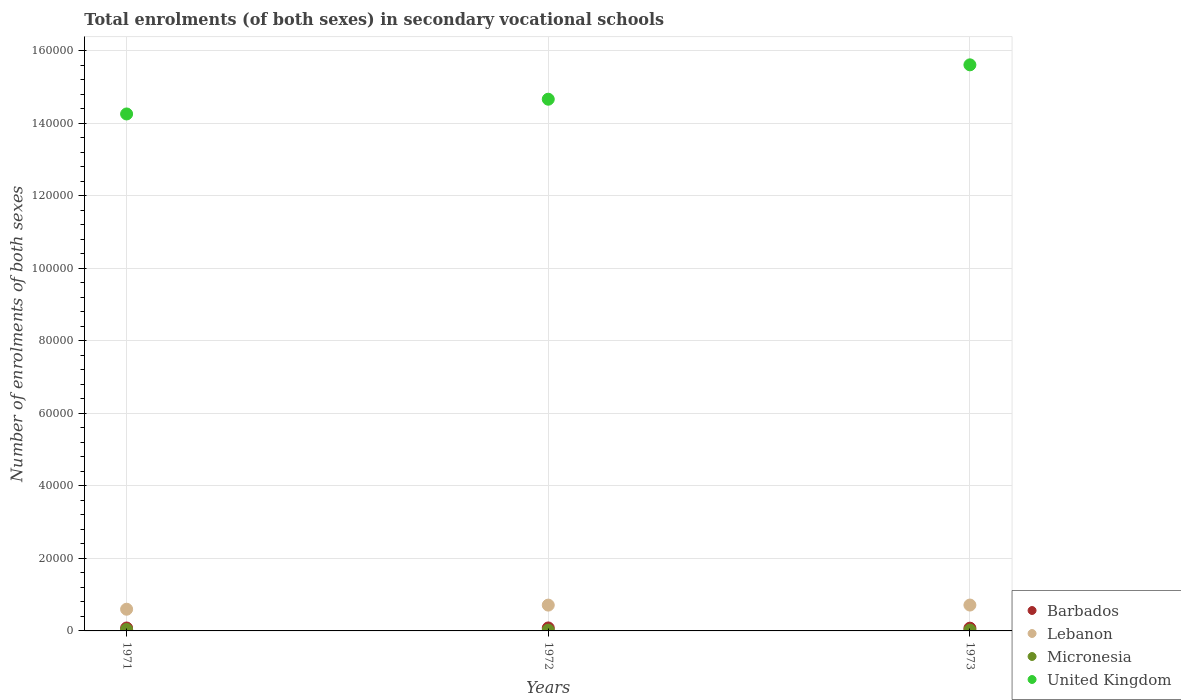How many different coloured dotlines are there?
Offer a very short reply. 4. What is the number of enrolments in secondary schools in Micronesia in 1973?
Offer a terse response. 226. Across all years, what is the maximum number of enrolments in secondary schools in United Kingdom?
Keep it short and to the point. 1.56e+05. Across all years, what is the minimum number of enrolments in secondary schools in Barbados?
Your response must be concise. 761. What is the total number of enrolments in secondary schools in Lebanon in the graph?
Provide a succinct answer. 2.02e+04. What is the difference between the number of enrolments in secondary schools in Micronesia in 1973 and the number of enrolments in secondary schools in Barbados in 1972?
Provide a short and direct response. -596. What is the average number of enrolments in secondary schools in Barbados per year?
Offer a terse response. 796.33. In the year 1971, what is the difference between the number of enrolments in secondary schools in United Kingdom and number of enrolments in secondary schools in Barbados?
Ensure brevity in your answer.  1.42e+05. In how many years, is the number of enrolments in secondary schools in United Kingdom greater than 8000?
Provide a succinct answer. 3. What is the ratio of the number of enrolments in secondary schools in Barbados in 1971 to that in 1973?
Give a very brief answer. 1.06. Is the number of enrolments in secondary schools in Micronesia in 1971 less than that in 1973?
Make the answer very short. No. What is the difference between the highest and the second highest number of enrolments in secondary schools in United Kingdom?
Provide a short and direct response. 9479. What is the difference between the highest and the lowest number of enrolments in secondary schools in Lebanon?
Your answer should be very brief. 1150. In how many years, is the number of enrolments in secondary schools in United Kingdom greater than the average number of enrolments in secondary schools in United Kingdom taken over all years?
Offer a very short reply. 1. Is it the case that in every year, the sum of the number of enrolments in secondary schools in United Kingdom and number of enrolments in secondary schools in Lebanon  is greater than the sum of number of enrolments in secondary schools in Micronesia and number of enrolments in secondary schools in Barbados?
Provide a succinct answer. Yes. Is it the case that in every year, the sum of the number of enrolments in secondary schools in Barbados and number of enrolments in secondary schools in United Kingdom  is greater than the number of enrolments in secondary schools in Micronesia?
Offer a very short reply. Yes. Is the number of enrolments in secondary schools in United Kingdom strictly less than the number of enrolments in secondary schools in Barbados over the years?
Keep it short and to the point. No. How many years are there in the graph?
Give a very brief answer. 3. What is the difference between two consecutive major ticks on the Y-axis?
Keep it short and to the point. 2.00e+04. Does the graph contain any zero values?
Your answer should be compact. No. Does the graph contain grids?
Keep it short and to the point. Yes. Where does the legend appear in the graph?
Provide a succinct answer. Bottom right. How many legend labels are there?
Your answer should be very brief. 4. What is the title of the graph?
Provide a short and direct response. Total enrolments (of both sexes) in secondary vocational schools. What is the label or title of the Y-axis?
Your answer should be very brief. Number of enrolments of both sexes. What is the Number of enrolments of both sexes in Barbados in 1971?
Give a very brief answer. 806. What is the Number of enrolments of both sexes of Lebanon in 1971?
Make the answer very short. 5983. What is the Number of enrolments of both sexes in Micronesia in 1971?
Provide a succinct answer. 409. What is the Number of enrolments of both sexes in United Kingdom in 1971?
Your answer should be compact. 1.43e+05. What is the Number of enrolments of both sexes in Barbados in 1972?
Your answer should be compact. 822. What is the Number of enrolments of both sexes in Lebanon in 1972?
Make the answer very short. 7117. What is the Number of enrolments of both sexes of Micronesia in 1972?
Ensure brevity in your answer.  215. What is the Number of enrolments of both sexes in United Kingdom in 1972?
Offer a terse response. 1.47e+05. What is the Number of enrolments of both sexes in Barbados in 1973?
Your answer should be compact. 761. What is the Number of enrolments of both sexes in Lebanon in 1973?
Ensure brevity in your answer.  7133. What is the Number of enrolments of both sexes in Micronesia in 1973?
Your answer should be very brief. 226. What is the Number of enrolments of both sexes of United Kingdom in 1973?
Your response must be concise. 1.56e+05. Across all years, what is the maximum Number of enrolments of both sexes in Barbados?
Offer a very short reply. 822. Across all years, what is the maximum Number of enrolments of both sexes of Lebanon?
Ensure brevity in your answer.  7133. Across all years, what is the maximum Number of enrolments of both sexes in Micronesia?
Offer a very short reply. 409. Across all years, what is the maximum Number of enrolments of both sexes of United Kingdom?
Keep it short and to the point. 1.56e+05. Across all years, what is the minimum Number of enrolments of both sexes in Barbados?
Offer a terse response. 761. Across all years, what is the minimum Number of enrolments of both sexes in Lebanon?
Ensure brevity in your answer.  5983. Across all years, what is the minimum Number of enrolments of both sexes of Micronesia?
Ensure brevity in your answer.  215. Across all years, what is the minimum Number of enrolments of both sexes in United Kingdom?
Provide a short and direct response. 1.43e+05. What is the total Number of enrolments of both sexes of Barbados in the graph?
Ensure brevity in your answer.  2389. What is the total Number of enrolments of both sexes in Lebanon in the graph?
Your response must be concise. 2.02e+04. What is the total Number of enrolments of both sexes in Micronesia in the graph?
Make the answer very short. 850. What is the total Number of enrolments of both sexes of United Kingdom in the graph?
Keep it short and to the point. 4.45e+05. What is the difference between the Number of enrolments of both sexes in Barbados in 1971 and that in 1972?
Provide a short and direct response. -16. What is the difference between the Number of enrolments of both sexes in Lebanon in 1971 and that in 1972?
Your response must be concise. -1134. What is the difference between the Number of enrolments of both sexes in Micronesia in 1971 and that in 1972?
Make the answer very short. 194. What is the difference between the Number of enrolments of both sexes in United Kingdom in 1971 and that in 1972?
Provide a succinct answer. -4064. What is the difference between the Number of enrolments of both sexes in Lebanon in 1971 and that in 1973?
Offer a very short reply. -1150. What is the difference between the Number of enrolments of both sexes in Micronesia in 1971 and that in 1973?
Keep it short and to the point. 183. What is the difference between the Number of enrolments of both sexes of United Kingdom in 1971 and that in 1973?
Offer a terse response. -1.35e+04. What is the difference between the Number of enrolments of both sexes in Lebanon in 1972 and that in 1973?
Provide a succinct answer. -16. What is the difference between the Number of enrolments of both sexes of United Kingdom in 1972 and that in 1973?
Ensure brevity in your answer.  -9479. What is the difference between the Number of enrolments of both sexes in Barbados in 1971 and the Number of enrolments of both sexes in Lebanon in 1972?
Provide a short and direct response. -6311. What is the difference between the Number of enrolments of both sexes of Barbados in 1971 and the Number of enrolments of both sexes of Micronesia in 1972?
Give a very brief answer. 591. What is the difference between the Number of enrolments of both sexes of Barbados in 1971 and the Number of enrolments of both sexes of United Kingdom in 1972?
Make the answer very short. -1.46e+05. What is the difference between the Number of enrolments of both sexes in Lebanon in 1971 and the Number of enrolments of both sexes in Micronesia in 1972?
Keep it short and to the point. 5768. What is the difference between the Number of enrolments of both sexes in Lebanon in 1971 and the Number of enrolments of both sexes in United Kingdom in 1972?
Provide a succinct answer. -1.41e+05. What is the difference between the Number of enrolments of both sexes in Micronesia in 1971 and the Number of enrolments of both sexes in United Kingdom in 1972?
Ensure brevity in your answer.  -1.46e+05. What is the difference between the Number of enrolments of both sexes of Barbados in 1971 and the Number of enrolments of both sexes of Lebanon in 1973?
Your answer should be very brief. -6327. What is the difference between the Number of enrolments of both sexes of Barbados in 1971 and the Number of enrolments of both sexes of Micronesia in 1973?
Make the answer very short. 580. What is the difference between the Number of enrolments of both sexes of Barbados in 1971 and the Number of enrolments of both sexes of United Kingdom in 1973?
Offer a terse response. -1.55e+05. What is the difference between the Number of enrolments of both sexes of Lebanon in 1971 and the Number of enrolments of both sexes of Micronesia in 1973?
Make the answer very short. 5757. What is the difference between the Number of enrolments of both sexes of Lebanon in 1971 and the Number of enrolments of both sexes of United Kingdom in 1973?
Make the answer very short. -1.50e+05. What is the difference between the Number of enrolments of both sexes in Micronesia in 1971 and the Number of enrolments of both sexes in United Kingdom in 1973?
Make the answer very short. -1.56e+05. What is the difference between the Number of enrolments of both sexes in Barbados in 1972 and the Number of enrolments of both sexes in Lebanon in 1973?
Offer a very short reply. -6311. What is the difference between the Number of enrolments of both sexes in Barbados in 1972 and the Number of enrolments of both sexes in Micronesia in 1973?
Provide a short and direct response. 596. What is the difference between the Number of enrolments of both sexes in Barbados in 1972 and the Number of enrolments of both sexes in United Kingdom in 1973?
Make the answer very short. -1.55e+05. What is the difference between the Number of enrolments of both sexes of Lebanon in 1972 and the Number of enrolments of both sexes of Micronesia in 1973?
Keep it short and to the point. 6891. What is the difference between the Number of enrolments of both sexes of Lebanon in 1972 and the Number of enrolments of both sexes of United Kingdom in 1973?
Offer a very short reply. -1.49e+05. What is the difference between the Number of enrolments of both sexes in Micronesia in 1972 and the Number of enrolments of both sexes in United Kingdom in 1973?
Offer a terse response. -1.56e+05. What is the average Number of enrolments of both sexes of Barbados per year?
Keep it short and to the point. 796.33. What is the average Number of enrolments of both sexes of Lebanon per year?
Your answer should be very brief. 6744.33. What is the average Number of enrolments of both sexes of Micronesia per year?
Your answer should be compact. 283.33. What is the average Number of enrolments of both sexes of United Kingdom per year?
Your response must be concise. 1.48e+05. In the year 1971, what is the difference between the Number of enrolments of both sexes of Barbados and Number of enrolments of both sexes of Lebanon?
Provide a succinct answer. -5177. In the year 1971, what is the difference between the Number of enrolments of both sexes of Barbados and Number of enrolments of both sexes of Micronesia?
Ensure brevity in your answer.  397. In the year 1971, what is the difference between the Number of enrolments of both sexes in Barbados and Number of enrolments of both sexes in United Kingdom?
Your answer should be compact. -1.42e+05. In the year 1971, what is the difference between the Number of enrolments of both sexes of Lebanon and Number of enrolments of both sexes of Micronesia?
Give a very brief answer. 5574. In the year 1971, what is the difference between the Number of enrolments of both sexes of Lebanon and Number of enrolments of both sexes of United Kingdom?
Your answer should be compact. -1.37e+05. In the year 1971, what is the difference between the Number of enrolments of both sexes in Micronesia and Number of enrolments of both sexes in United Kingdom?
Your answer should be very brief. -1.42e+05. In the year 1972, what is the difference between the Number of enrolments of both sexes of Barbados and Number of enrolments of both sexes of Lebanon?
Give a very brief answer. -6295. In the year 1972, what is the difference between the Number of enrolments of both sexes of Barbados and Number of enrolments of both sexes of Micronesia?
Provide a short and direct response. 607. In the year 1972, what is the difference between the Number of enrolments of both sexes in Barbados and Number of enrolments of both sexes in United Kingdom?
Ensure brevity in your answer.  -1.46e+05. In the year 1972, what is the difference between the Number of enrolments of both sexes in Lebanon and Number of enrolments of both sexes in Micronesia?
Offer a terse response. 6902. In the year 1972, what is the difference between the Number of enrolments of both sexes in Lebanon and Number of enrolments of both sexes in United Kingdom?
Ensure brevity in your answer.  -1.39e+05. In the year 1972, what is the difference between the Number of enrolments of both sexes of Micronesia and Number of enrolments of both sexes of United Kingdom?
Make the answer very short. -1.46e+05. In the year 1973, what is the difference between the Number of enrolments of both sexes of Barbados and Number of enrolments of both sexes of Lebanon?
Offer a very short reply. -6372. In the year 1973, what is the difference between the Number of enrolments of both sexes in Barbados and Number of enrolments of both sexes in Micronesia?
Offer a very short reply. 535. In the year 1973, what is the difference between the Number of enrolments of both sexes in Barbados and Number of enrolments of both sexes in United Kingdom?
Provide a succinct answer. -1.55e+05. In the year 1973, what is the difference between the Number of enrolments of both sexes of Lebanon and Number of enrolments of both sexes of Micronesia?
Your answer should be very brief. 6907. In the year 1973, what is the difference between the Number of enrolments of both sexes in Lebanon and Number of enrolments of both sexes in United Kingdom?
Ensure brevity in your answer.  -1.49e+05. In the year 1973, what is the difference between the Number of enrolments of both sexes of Micronesia and Number of enrolments of both sexes of United Kingdom?
Keep it short and to the point. -1.56e+05. What is the ratio of the Number of enrolments of both sexes of Barbados in 1971 to that in 1972?
Give a very brief answer. 0.98. What is the ratio of the Number of enrolments of both sexes in Lebanon in 1971 to that in 1972?
Give a very brief answer. 0.84. What is the ratio of the Number of enrolments of both sexes of Micronesia in 1971 to that in 1972?
Provide a succinct answer. 1.9. What is the ratio of the Number of enrolments of both sexes in United Kingdom in 1971 to that in 1972?
Offer a terse response. 0.97. What is the ratio of the Number of enrolments of both sexes of Barbados in 1971 to that in 1973?
Your response must be concise. 1.06. What is the ratio of the Number of enrolments of both sexes of Lebanon in 1971 to that in 1973?
Your answer should be compact. 0.84. What is the ratio of the Number of enrolments of both sexes of Micronesia in 1971 to that in 1973?
Make the answer very short. 1.81. What is the ratio of the Number of enrolments of both sexes in United Kingdom in 1971 to that in 1973?
Keep it short and to the point. 0.91. What is the ratio of the Number of enrolments of both sexes of Barbados in 1972 to that in 1973?
Provide a short and direct response. 1.08. What is the ratio of the Number of enrolments of both sexes of Micronesia in 1972 to that in 1973?
Offer a very short reply. 0.95. What is the ratio of the Number of enrolments of both sexes in United Kingdom in 1972 to that in 1973?
Your answer should be compact. 0.94. What is the difference between the highest and the second highest Number of enrolments of both sexes of Barbados?
Your answer should be very brief. 16. What is the difference between the highest and the second highest Number of enrolments of both sexes in Micronesia?
Your response must be concise. 183. What is the difference between the highest and the second highest Number of enrolments of both sexes in United Kingdom?
Keep it short and to the point. 9479. What is the difference between the highest and the lowest Number of enrolments of both sexes in Lebanon?
Make the answer very short. 1150. What is the difference between the highest and the lowest Number of enrolments of both sexes in Micronesia?
Your answer should be compact. 194. What is the difference between the highest and the lowest Number of enrolments of both sexes of United Kingdom?
Ensure brevity in your answer.  1.35e+04. 